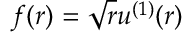<formula> <loc_0><loc_0><loc_500><loc_500>f ( r ) = \sqrt { r } u ^ { ( 1 ) } ( r )</formula> 